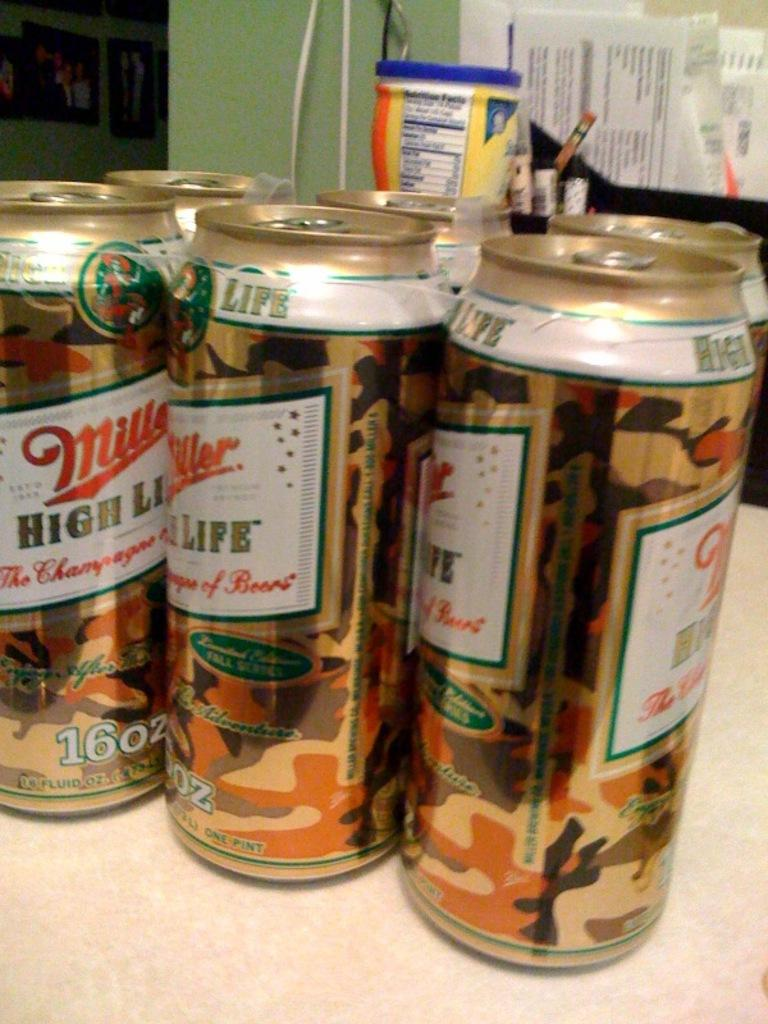Provide a one-sentence caption for the provided image. Six cans of Miler High Life sit on a table. 